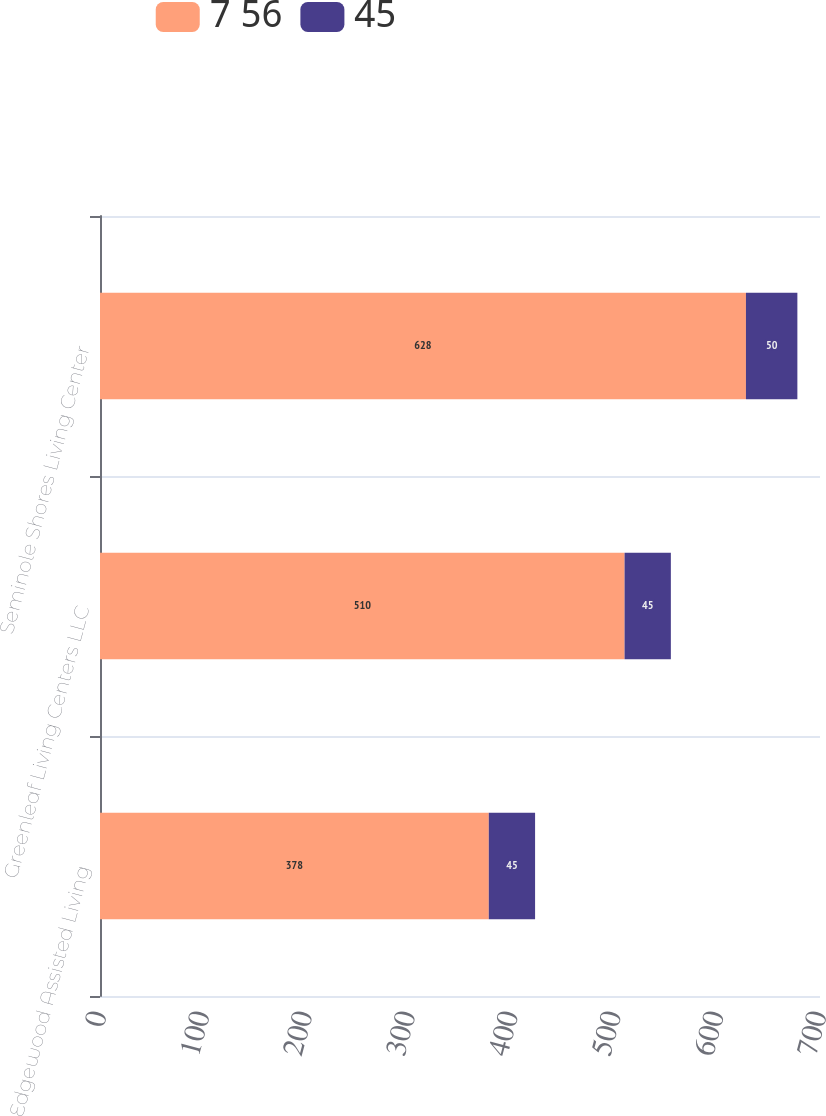Convert chart. <chart><loc_0><loc_0><loc_500><loc_500><stacked_bar_chart><ecel><fcel>Edgewood Assisted Living<fcel>Greenleaf Living Centers LLC<fcel>Seminole Shores Living Center<nl><fcel>7 56<fcel>378<fcel>510<fcel>628<nl><fcel>45<fcel>45<fcel>45<fcel>50<nl></chart> 